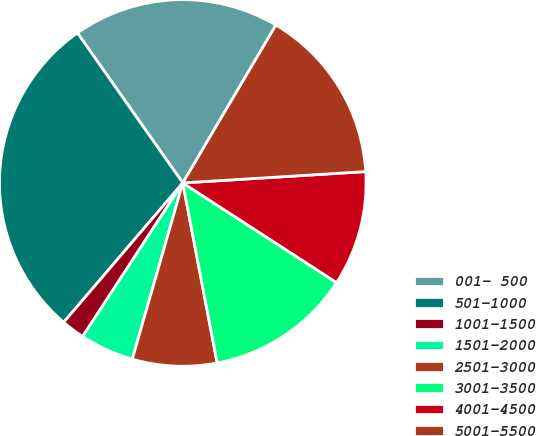Convert chart. <chart><loc_0><loc_0><loc_500><loc_500><pie_chart><fcel>001- 500<fcel>501-1000<fcel>1001-1500<fcel>1501-2000<fcel>2501-3000<fcel>3001-3500<fcel>4001-4500<fcel>5001-5500<nl><fcel>18.23%<fcel>29.0%<fcel>2.06%<fcel>4.75%<fcel>7.45%<fcel>12.84%<fcel>10.14%<fcel>15.53%<nl></chart> 